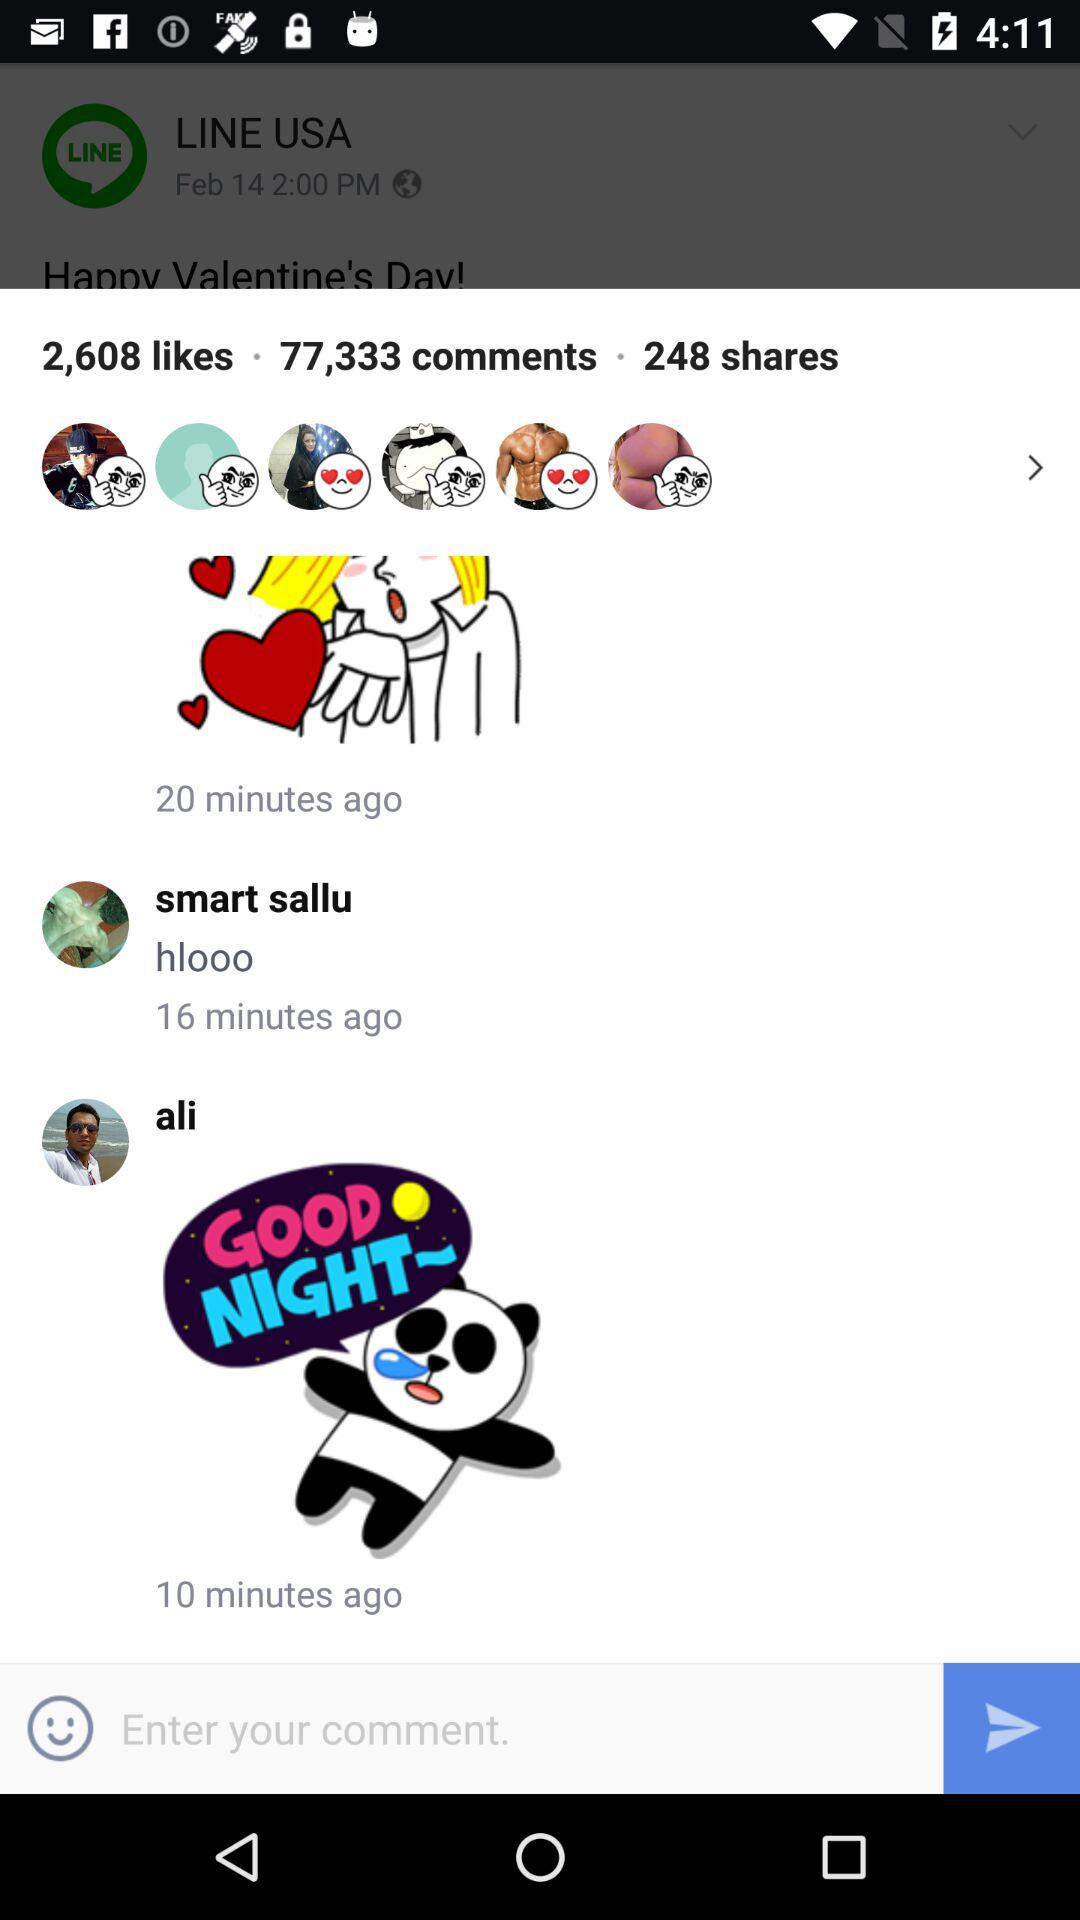How many shares are there? There are 248 shares. 